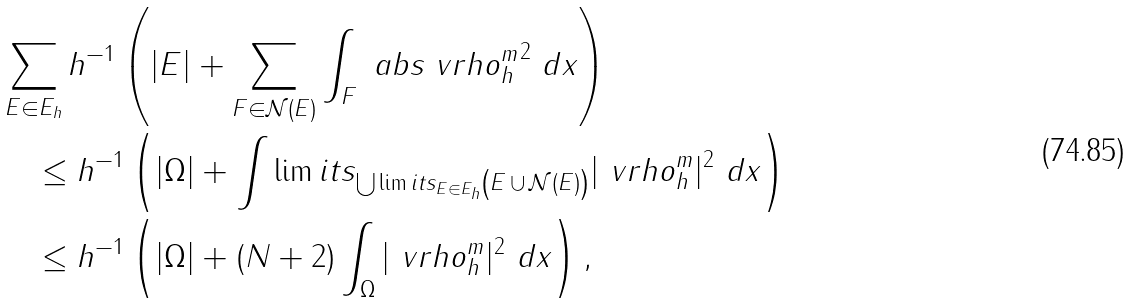Convert formula to latex. <formula><loc_0><loc_0><loc_500><loc_500>& \sum _ { E \in E _ { h } } h ^ { - 1 } \left ( | E | + \sum _ { F \in \mathcal { N } ( E ) } \int _ { F } \ a b s { \ v r h o _ { h } ^ { m } } ^ { 2 } \ d x \right ) \\ & \quad \leq h ^ { - 1 } \left ( | \Omega | + \int \lim i t s _ { \bigcup \lim i t s _ { E \in E _ { h } } \left ( E \, \cup \, \mathcal { N } ( E ) \right ) } | \ v r h o _ { h } ^ { m } | ^ { 2 } \ d x \right ) \\ & \quad \leq h ^ { - 1 } \left ( | \Omega | + ( N + 2 ) \int _ { \Omega } | \ v r h o _ { h } ^ { m } | ^ { 2 } \ d x \right ) ,</formula> 